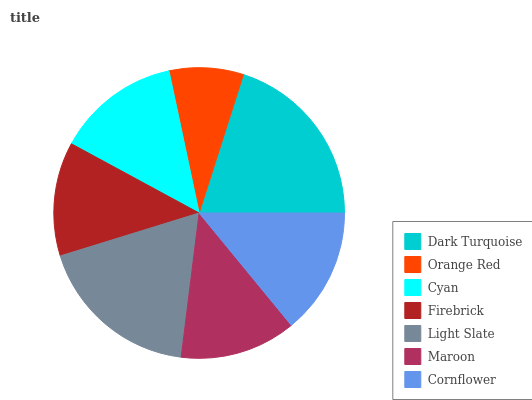Is Orange Red the minimum?
Answer yes or no. Yes. Is Dark Turquoise the maximum?
Answer yes or no. Yes. Is Cyan the minimum?
Answer yes or no. No. Is Cyan the maximum?
Answer yes or no. No. Is Cyan greater than Orange Red?
Answer yes or no. Yes. Is Orange Red less than Cyan?
Answer yes or no. Yes. Is Orange Red greater than Cyan?
Answer yes or no. No. Is Cyan less than Orange Red?
Answer yes or no. No. Is Cyan the high median?
Answer yes or no. Yes. Is Cyan the low median?
Answer yes or no. Yes. Is Dark Turquoise the high median?
Answer yes or no. No. Is Firebrick the low median?
Answer yes or no. No. 